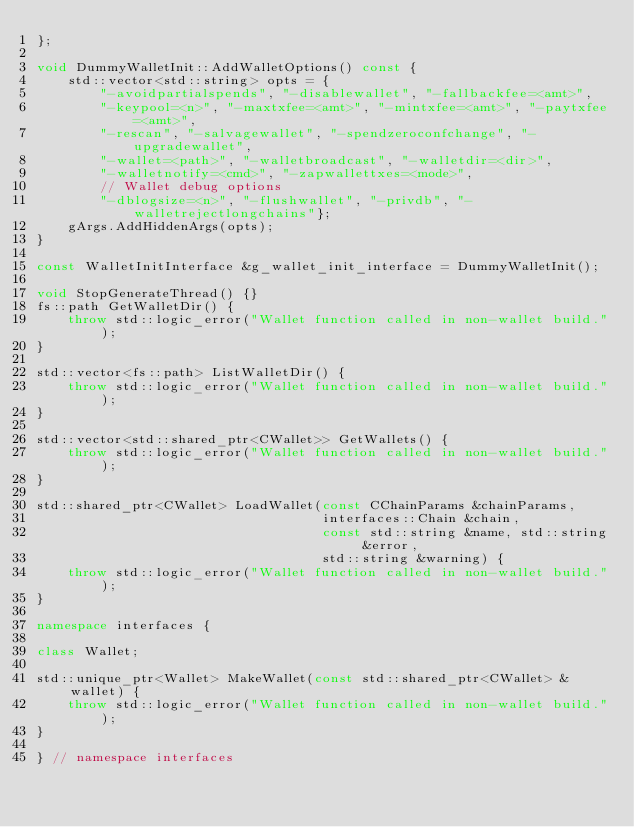Convert code to text. <code><loc_0><loc_0><loc_500><loc_500><_C++_>};

void DummyWalletInit::AddWalletOptions() const {
    std::vector<std::string> opts = {
        "-avoidpartialspends", "-disablewallet", "-fallbackfee=<amt>",
        "-keypool=<n>", "-maxtxfee=<amt>", "-mintxfee=<amt>", "-paytxfee=<amt>",
        "-rescan", "-salvagewallet", "-spendzeroconfchange", "-upgradewallet",
        "-wallet=<path>", "-walletbroadcast", "-walletdir=<dir>",
        "-walletnotify=<cmd>", "-zapwallettxes=<mode>",
        // Wallet debug options
        "-dblogsize=<n>", "-flushwallet", "-privdb", "-walletrejectlongchains"};
    gArgs.AddHiddenArgs(opts);
}

const WalletInitInterface &g_wallet_init_interface = DummyWalletInit();

void StopGenerateThread() {}
fs::path GetWalletDir() {
    throw std::logic_error("Wallet function called in non-wallet build.");
}

std::vector<fs::path> ListWalletDir() {
    throw std::logic_error("Wallet function called in non-wallet build.");
}

std::vector<std::shared_ptr<CWallet>> GetWallets() {
    throw std::logic_error("Wallet function called in non-wallet build.");
}

std::shared_ptr<CWallet> LoadWallet(const CChainParams &chainParams,
                                    interfaces::Chain &chain,
                                    const std::string &name, std::string &error,
                                    std::string &warning) {
    throw std::logic_error("Wallet function called in non-wallet build.");
}

namespace interfaces {

class Wallet;

std::unique_ptr<Wallet> MakeWallet(const std::shared_ptr<CWallet> &wallet) {
    throw std::logic_error("Wallet function called in non-wallet build.");
}

} // namespace interfaces
</code> 